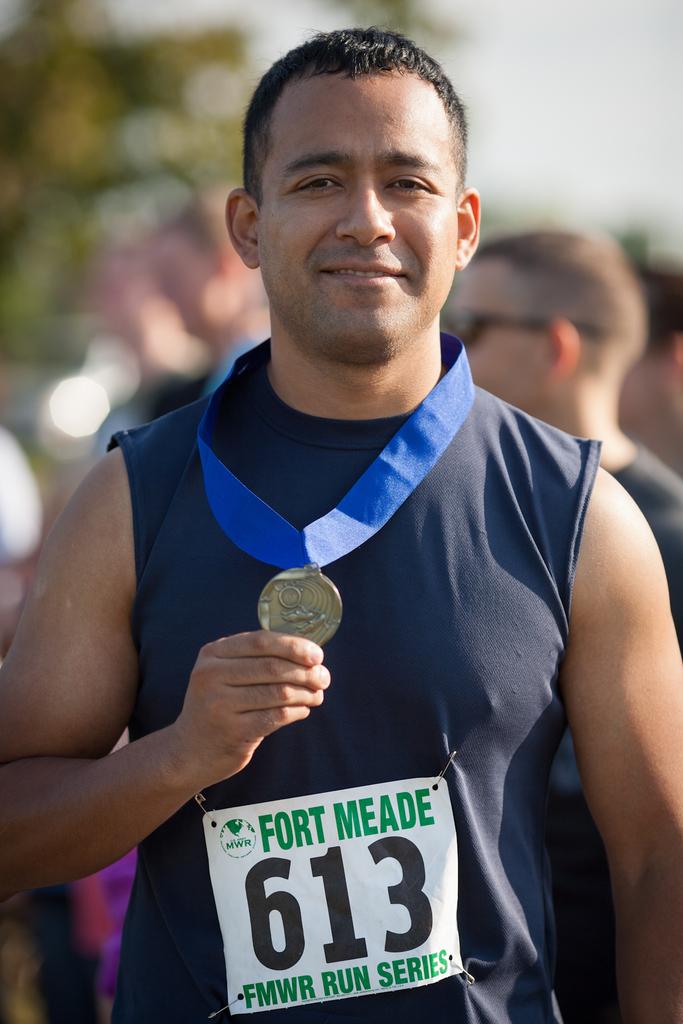What number is this contestant?
Provide a short and direct response. 613. 